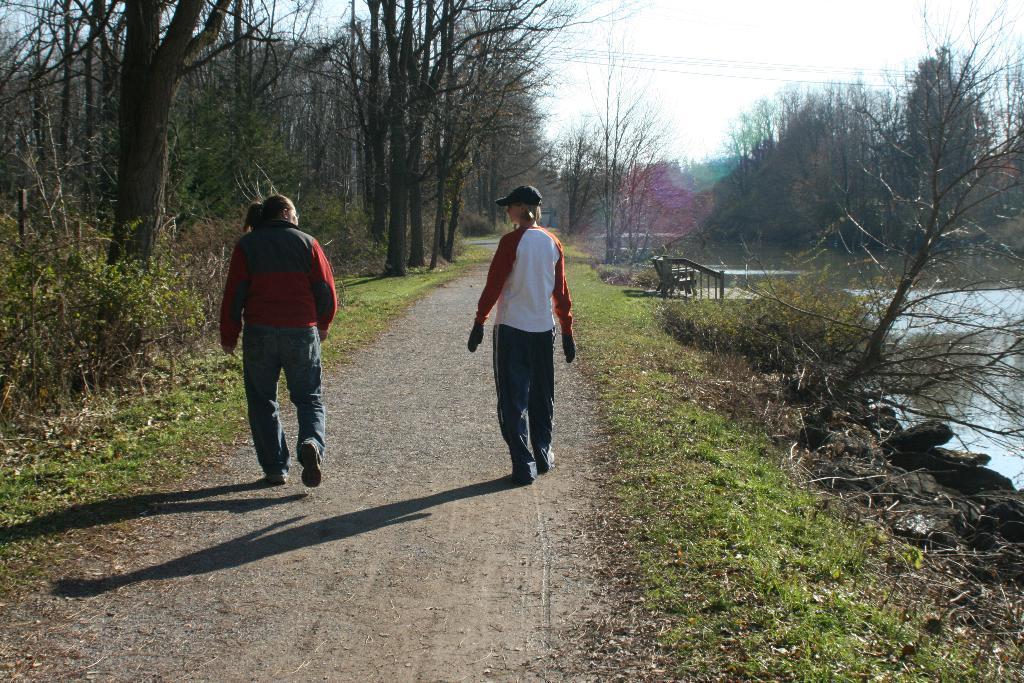In one or two sentences, can you explain what this image depicts? In this picture there are two persons walking on the way and there are few trees and a greenery ground on either sides of them and there is water in the right corner. 